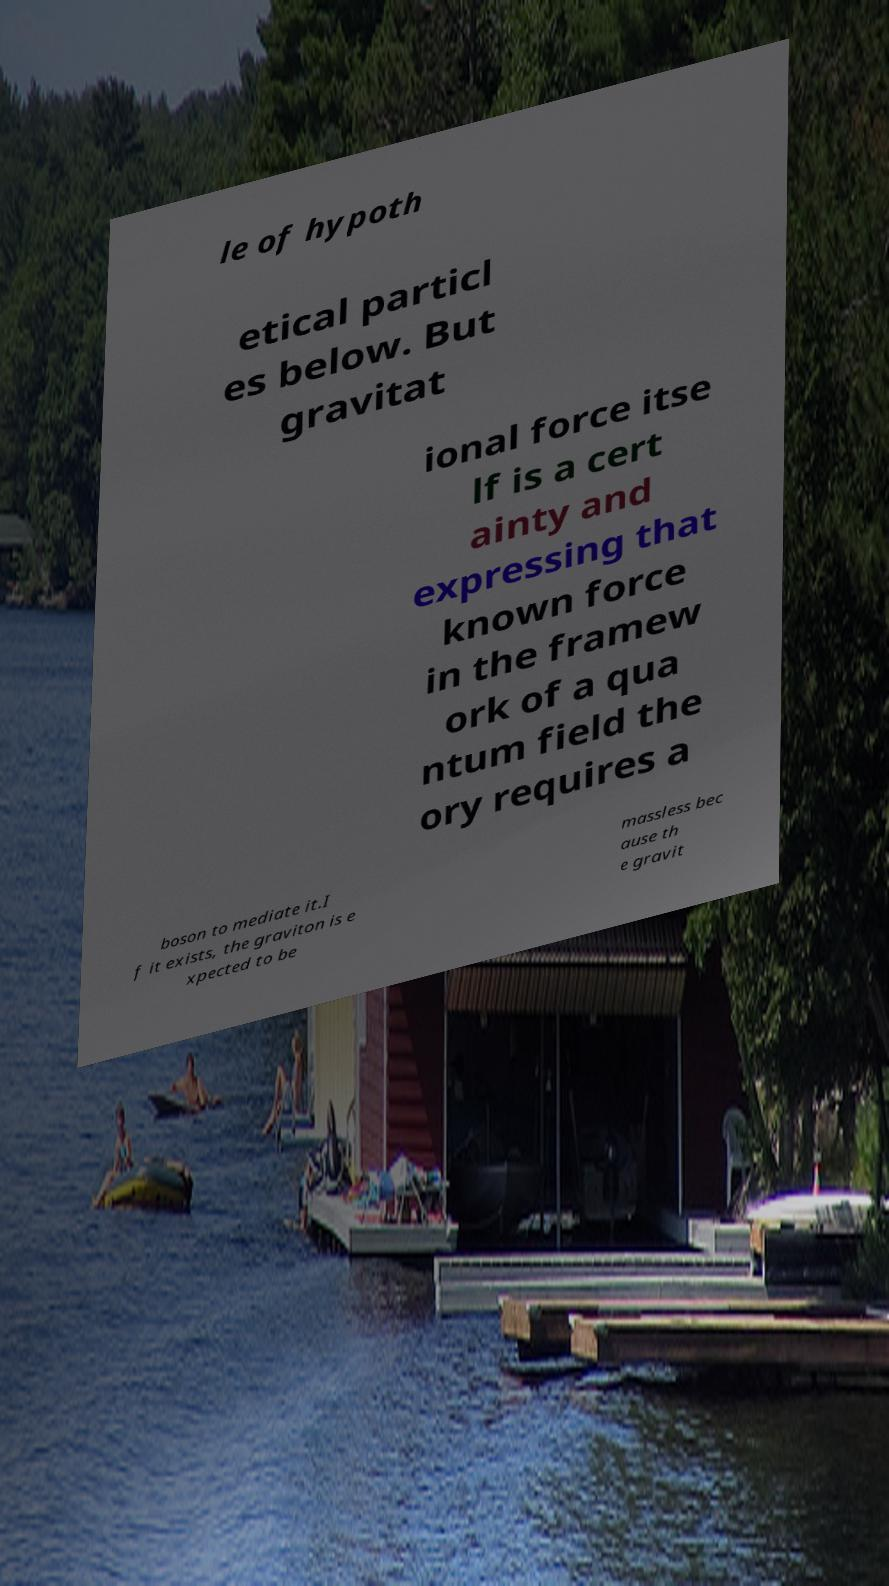Please read and relay the text visible in this image. What does it say? le of hypoth etical particl es below. But gravitat ional force itse lf is a cert ainty and expressing that known force in the framew ork of a qua ntum field the ory requires a boson to mediate it.I f it exists, the graviton is e xpected to be massless bec ause th e gravit 